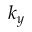Convert formula to latex. <formula><loc_0><loc_0><loc_500><loc_500>k _ { y }</formula> 